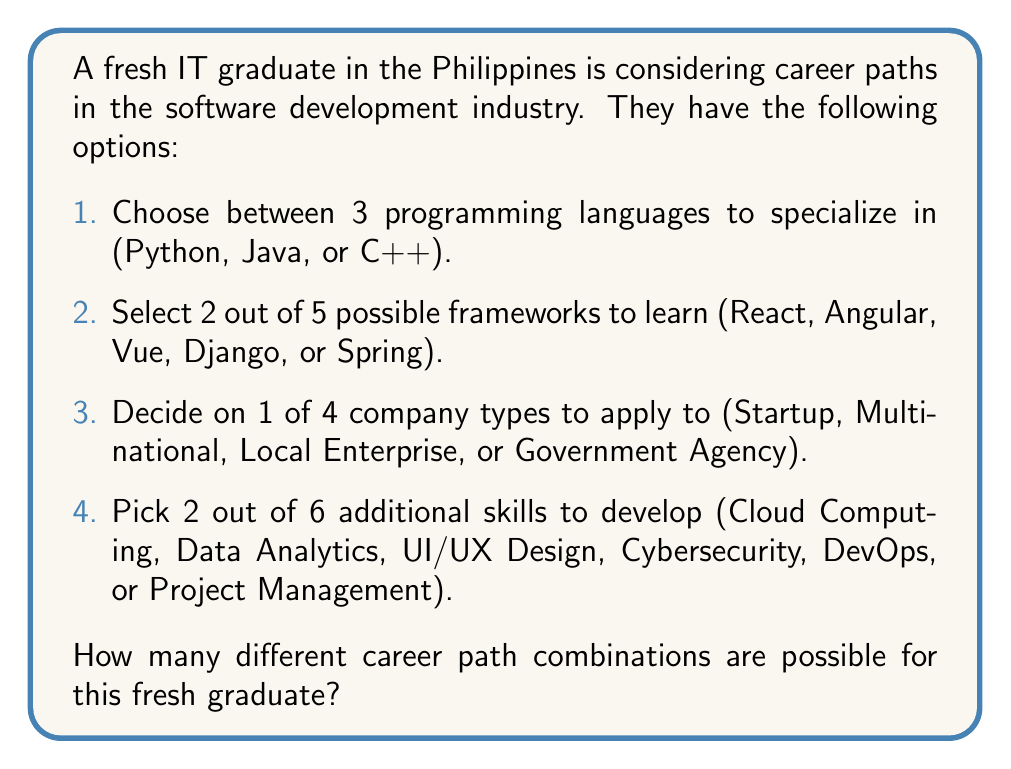Can you solve this math problem? Let's break this down step-by-step using the multiplication principle of counting:

1. Programming language choice:
   There are 3 options, so there are $3$ ways to make this choice.

2. Framework selection:
   The graduate needs to choose 2 out of 5 frameworks. This is a combination problem, represented as $\dbinom{5}{2}$.
   $$\dbinom{5}{2} = \frac{5!}{2!(5-2)!} = \frac{5 \cdot 4}{2 \cdot 1} = 10$$

3. Company type:
   There are 4 options, so there are $4$ ways to make this choice.

4. Additional skills:
   The graduate needs to choose 2 out of 6 skills. This is another combination, represented as $\dbinom{6}{2}$.
   $$\dbinom{6}{2} = \frac{6!}{2!(6-2)!} = \frac{6 \cdot 5}{2 \cdot 1} = 15$$

Now, we apply the multiplication principle. The total number of possible career path combinations is the product of the number of ways each choice can be made:

$$3 \cdot 10 \cdot 4 \cdot 15 = 1,800$$

Therefore, there are 1,800 different career path combinations possible for this fresh graduate.
Answer: 1,800 